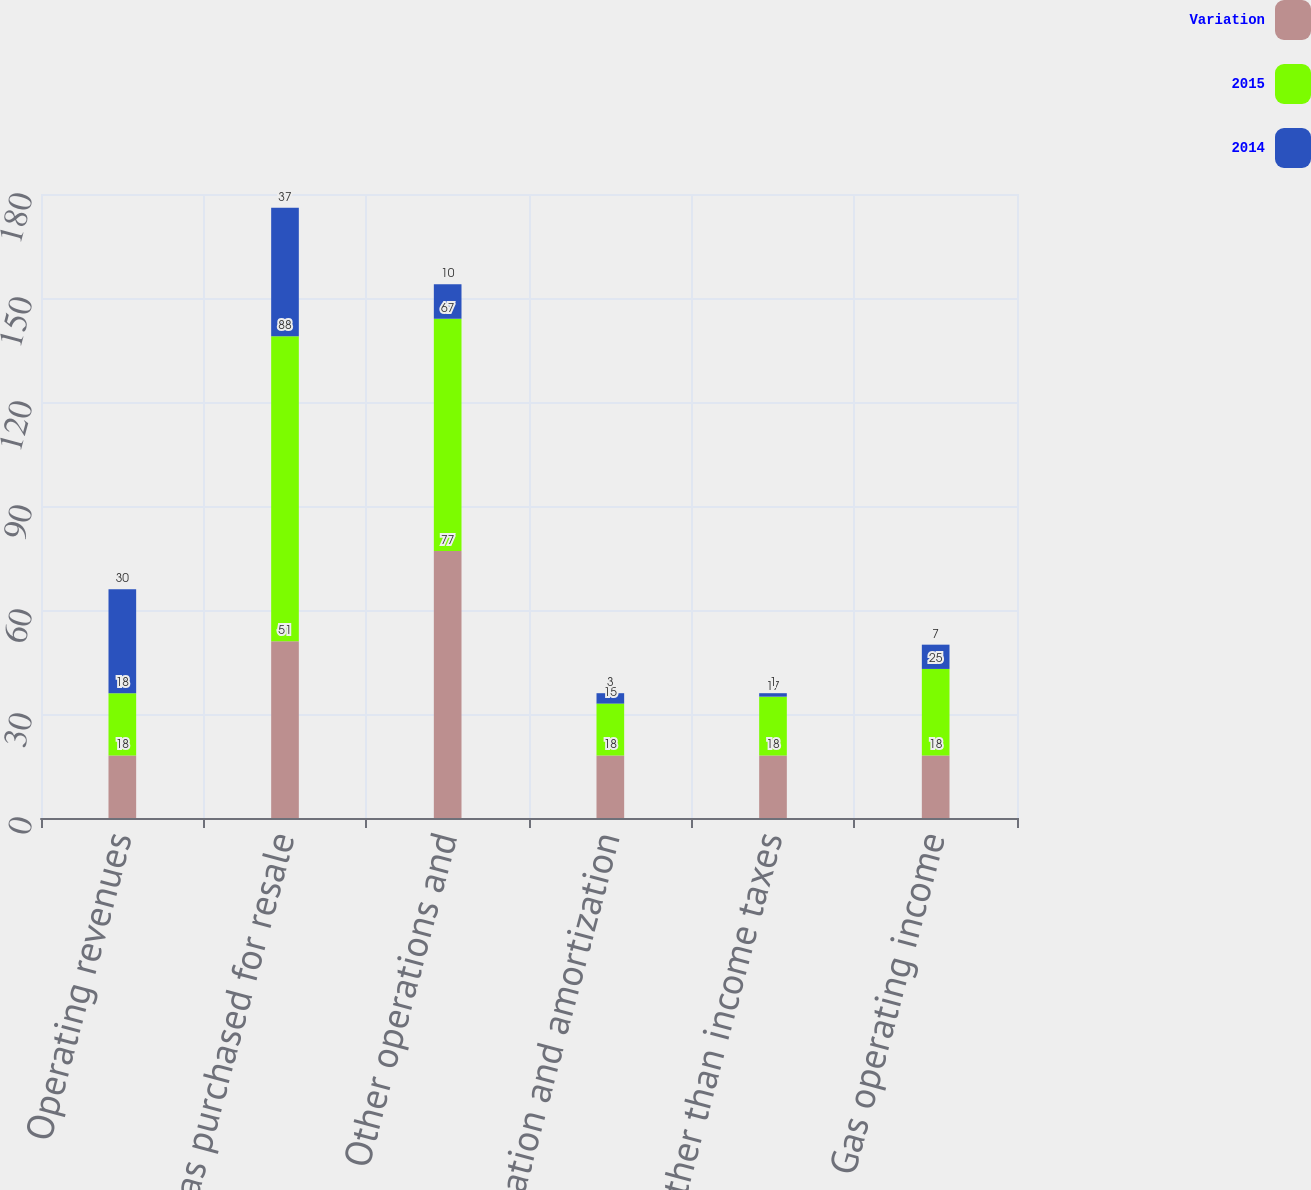Convert chart to OTSL. <chart><loc_0><loc_0><loc_500><loc_500><stacked_bar_chart><ecel><fcel>Operating revenues<fcel>Gas purchased for resale<fcel>Other operations and<fcel>Depreciation and amortization<fcel>Taxes other than income taxes<fcel>Gas operating income<nl><fcel>Variation<fcel>18<fcel>51<fcel>77<fcel>18<fcel>18<fcel>18<nl><fcel>2015<fcel>18<fcel>88<fcel>67<fcel>15<fcel>17<fcel>25<nl><fcel>2014<fcel>30<fcel>37<fcel>10<fcel>3<fcel>1<fcel>7<nl></chart> 